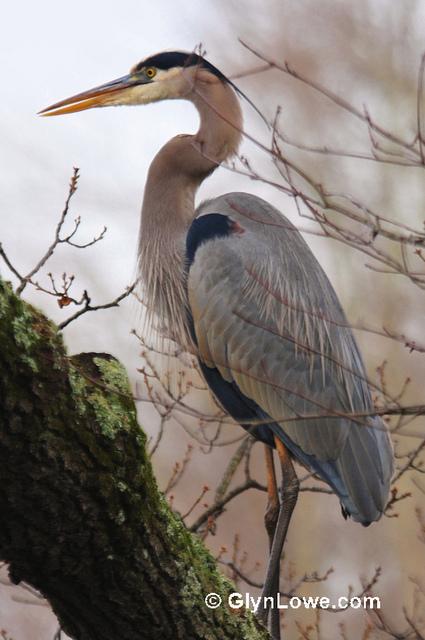Could this bird be a mammal?
Give a very brief answer. No. What kind of bird is this?
Quick response, please. Crane. What color are the birds eyes?
Write a very short answer. Yellow. 